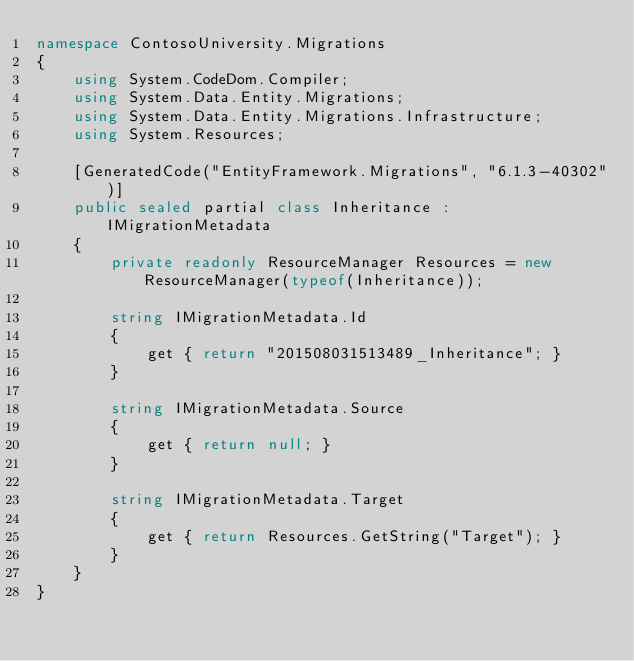Convert code to text. <code><loc_0><loc_0><loc_500><loc_500><_C#_>namespace ContosoUniversity.Migrations
{
    using System.CodeDom.Compiler;
    using System.Data.Entity.Migrations;
    using System.Data.Entity.Migrations.Infrastructure;
    using System.Resources;
    
    [GeneratedCode("EntityFramework.Migrations", "6.1.3-40302")]
    public sealed partial class Inheritance : IMigrationMetadata
    {
        private readonly ResourceManager Resources = new ResourceManager(typeof(Inheritance));
        
        string IMigrationMetadata.Id
        {
            get { return "201508031513489_Inheritance"; }
        }
        
        string IMigrationMetadata.Source
        {
            get { return null; }
        }
        
        string IMigrationMetadata.Target
        {
            get { return Resources.GetString("Target"); }
        }
    }
}
</code> 